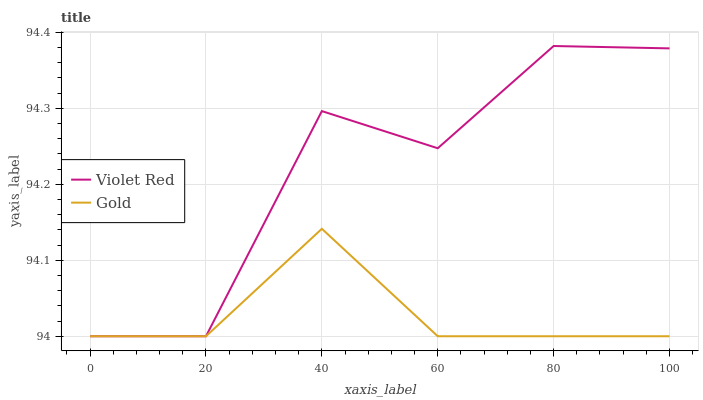Does Gold have the minimum area under the curve?
Answer yes or no. Yes. Does Violet Red have the maximum area under the curve?
Answer yes or no. Yes. Does Gold have the maximum area under the curve?
Answer yes or no. No. Is Gold the smoothest?
Answer yes or no. Yes. Is Violet Red the roughest?
Answer yes or no. Yes. Is Gold the roughest?
Answer yes or no. No. Does Violet Red have the lowest value?
Answer yes or no. Yes. Does Violet Red have the highest value?
Answer yes or no. Yes. Does Gold have the highest value?
Answer yes or no. No. Does Violet Red intersect Gold?
Answer yes or no. Yes. Is Violet Red less than Gold?
Answer yes or no. No. Is Violet Red greater than Gold?
Answer yes or no. No. 